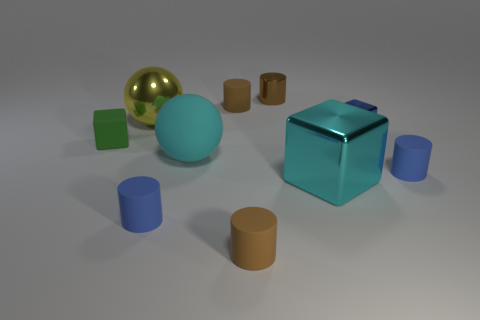Subtract all purple balls. How many blue cylinders are left? 2 Subtract all blue cylinders. How many cylinders are left? 3 Subtract 2 cylinders. How many cylinders are left? 3 Subtract all brown shiny cylinders. How many cylinders are left? 4 Subtract all purple cylinders. Subtract all purple cubes. How many cylinders are left? 5 Subtract all cubes. How many objects are left? 7 Add 7 small blue blocks. How many small blue blocks are left? 8 Add 8 cyan matte objects. How many cyan matte objects exist? 9 Subtract 1 blue blocks. How many objects are left? 9 Subtract all rubber balls. Subtract all metal cylinders. How many objects are left? 8 